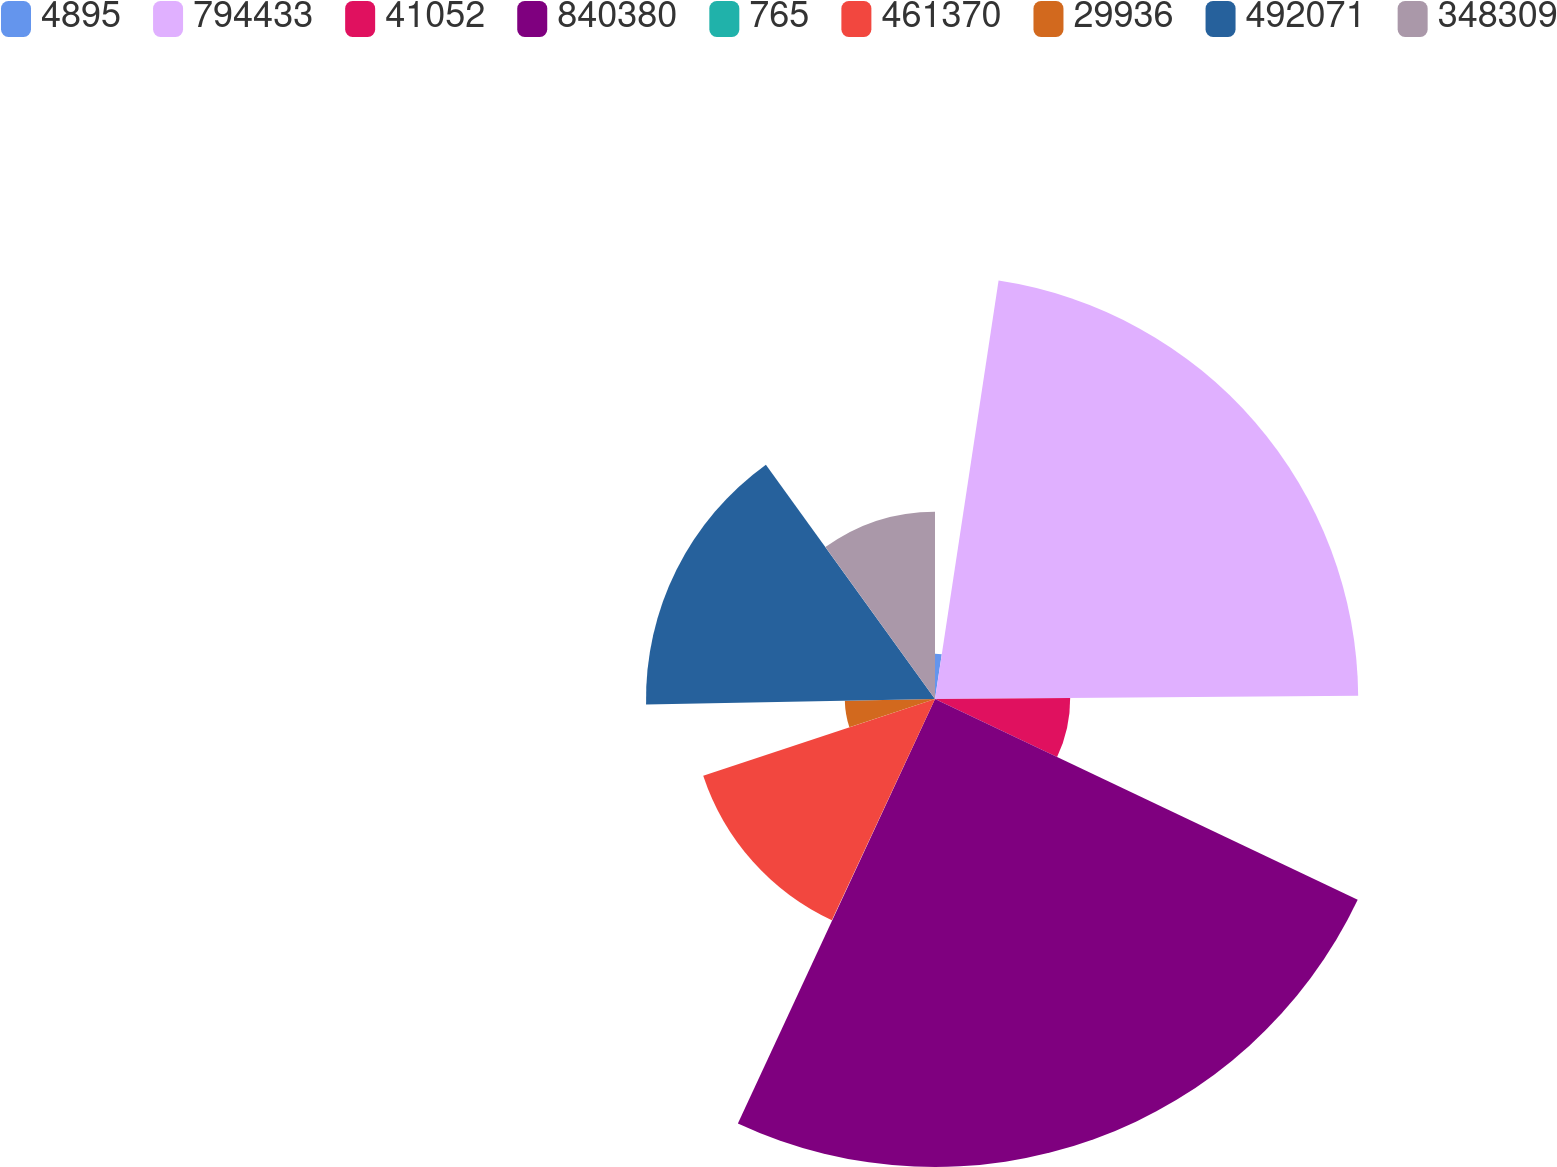Convert chart to OTSL. <chart><loc_0><loc_0><loc_500><loc_500><pie_chart><fcel>4895<fcel>794433<fcel>41052<fcel>840380<fcel>765<fcel>461370<fcel>29936<fcel>492071<fcel>348309<nl><fcel>2.4%<fcel>22.48%<fcel>7.18%<fcel>24.86%<fcel>0.02%<fcel>12.97%<fcel>4.79%<fcel>15.35%<fcel>9.95%<nl></chart> 